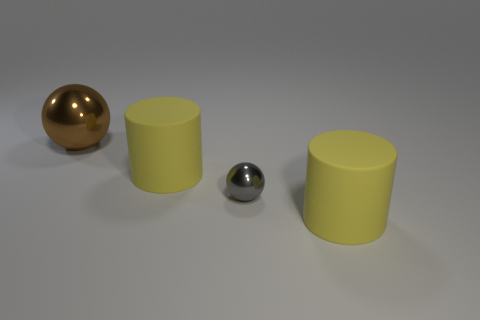What is the big thing that is both in front of the brown sphere and to the left of the small sphere made of?
Offer a terse response. Rubber. Are there any brown metal things that are in front of the metallic object that is to the right of the big sphere?
Your answer should be compact. No. There is a object that is to the left of the gray metallic object and in front of the brown shiny object; what size is it?
Provide a succinct answer. Large. How many gray objects are tiny shiny objects or big shiny things?
Provide a short and direct response. 1. What is the size of the metallic ball behind the sphere that is in front of the large metallic thing?
Give a very brief answer. Large. Does the big brown ball that is on the left side of the small sphere have the same material as the gray thing?
Your answer should be very brief. Yes. There is a object that is right of the tiny object; what shape is it?
Make the answer very short. Cylinder. What number of gray metal spheres have the same size as the brown thing?
Your response must be concise. 0. What size is the gray ball?
Keep it short and to the point. Small. There is a brown ball; how many metallic things are to the right of it?
Your response must be concise. 1. 